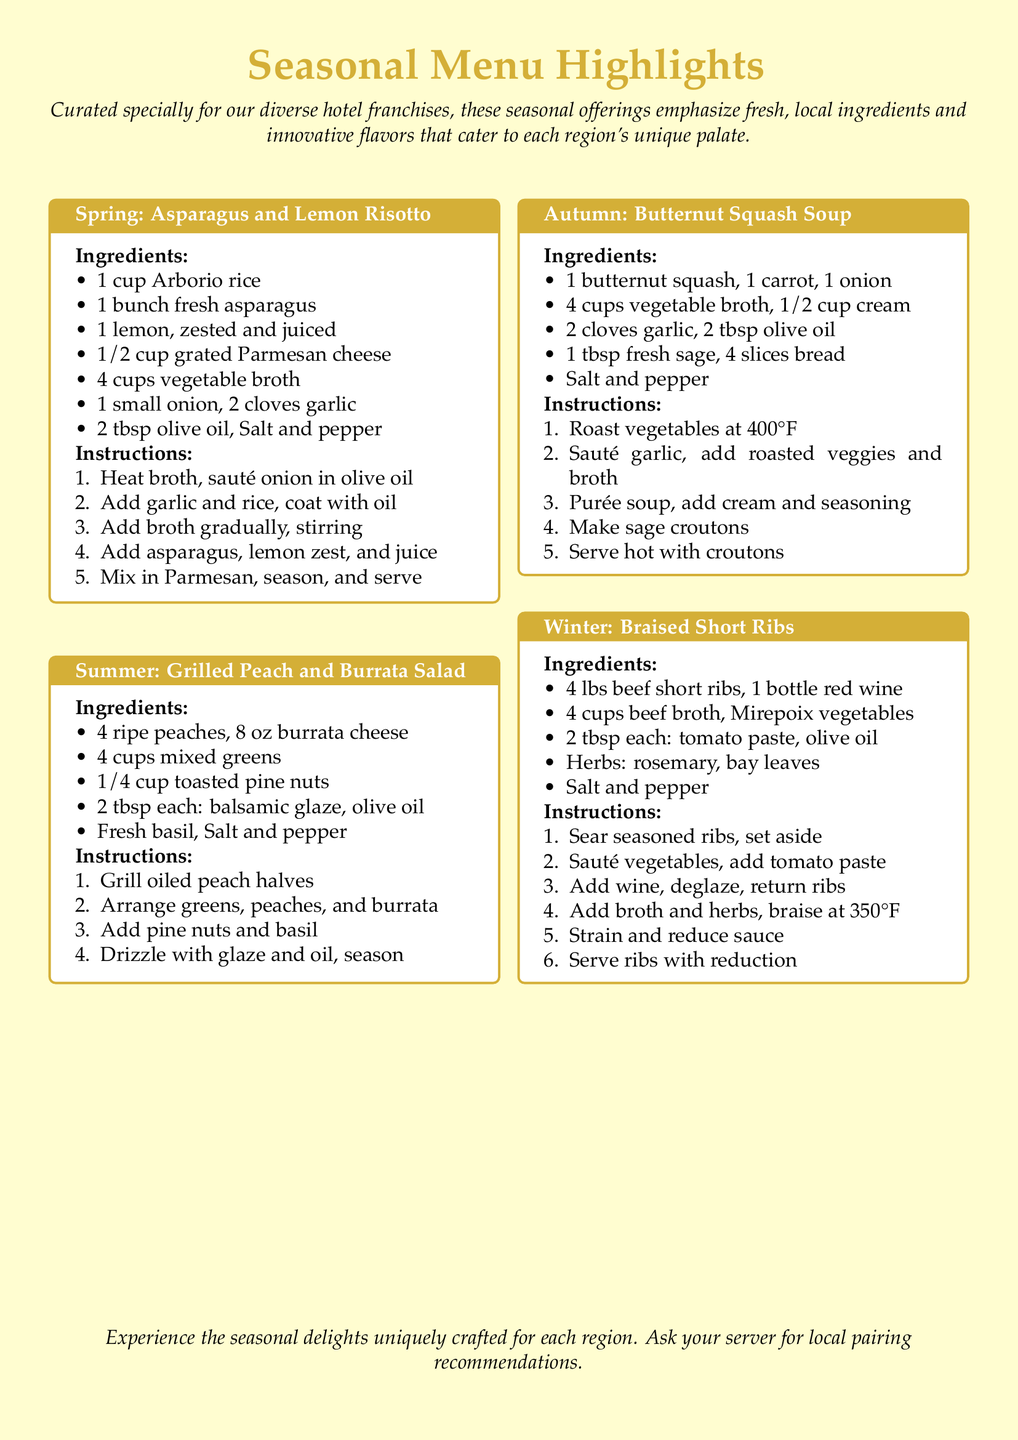What is the first ingredient in the Spring recipe? The first ingredient listed in the Spring recipe is Arborio rice.
Answer: Arborio rice How many ounces of burrata cheese are used in the Summer recipe? The Summer recipe specifies the use of 8 oz of burrata cheese.
Answer: 8 oz What is the cooking temperature for roasting vegetables in the Autumn recipe? The cooking temperature for roasting vegetables in the Autumn recipe is 400°F.
Answer: 400°F What main ingredient is used in the Winter recipe? The main ingredient in the Winter recipe is beef short ribs.
Answer: beef short ribs What type of cheese is used in the Summer salad? The type of cheese used in the Summer salad is burrata cheese.
Answer: burrata cheese How many cups of vegetable broth are needed for the Spring recipe? The Spring recipe requires 4 cups of vegetable broth.
Answer: 4 cups Which herb is featured in the Autumn soup? The herb featured in the Autumn soup is sage.
Answer: sage How is the cooking process for the Winter recipe initiated? The cooking process for the Winter recipe is initiated by searing seasoned ribs.
Answer: searing seasoned ribs What is advised to ask your server regarding the seasonal dishes? It is advised to ask your server for local pairing recommendations.
Answer: local pairing recommendations 